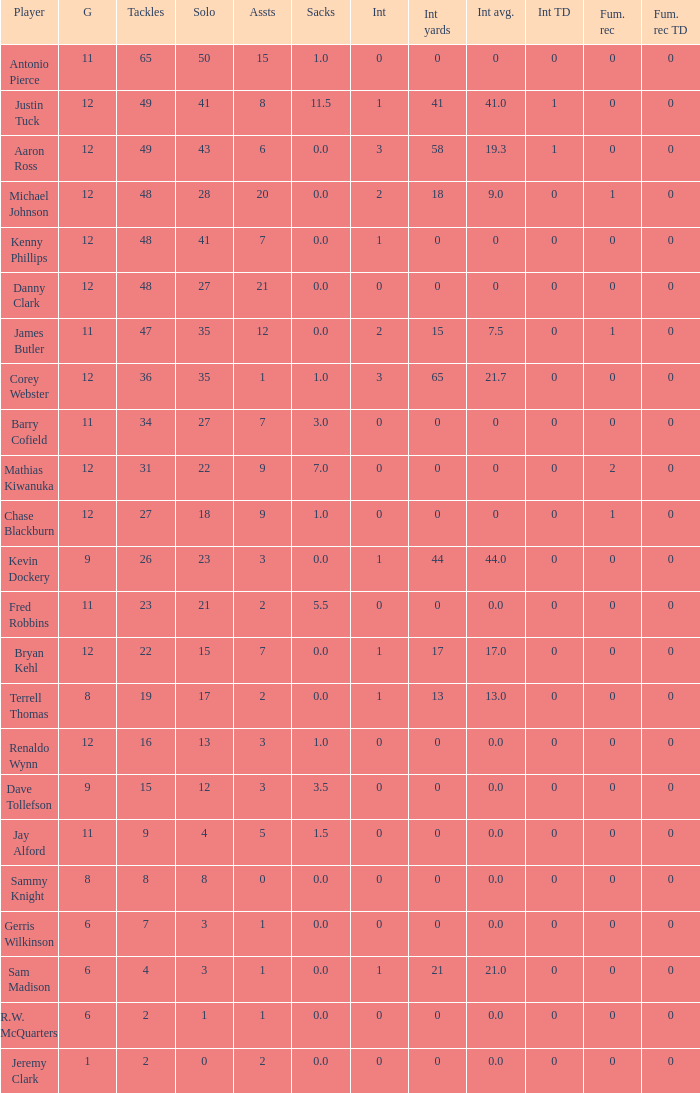Name the least fum rec td 0.0. 